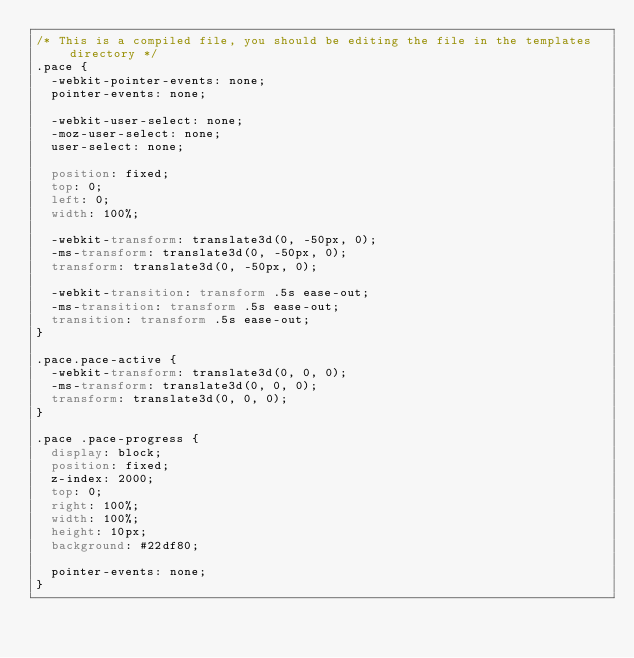Convert code to text. <code><loc_0><loc_0><loc_500><loc_500><_CSS_>/* This is a compiled file, you should be editing the file in the templates directory */
.pace {
  -webkit-pointer-events: none;
  pointer-events: none;

  -webkit-user-select: none;
  -moz-user-select: none;
  user-select: none;

  position: fixed;
  top: 0;
  left: 0;
  width: 100%;

  -webkit-transform: translate3d(0, -50px, 0);
  -ms-transform: translate3d(0, -50px, 0);
  transform: translate3d(0, -50px, 0);

  -webkit-transition: transform .5s ease-out;
  -ms-transition: transform .5s ease-out;
  transition: transform .5s ease-out;
}

.pace.pace-active {
  -webkit-transform: translate3d(0, 0, 0);
  -ms-transform: translate3d(0, 0, 0);
  transform: translate3d(0, 0, 0);
}

.pace .pace-progress {
  display: block;
  position: fixed;
  z-index: 2000;
  top: 0;
  right: 100%;
  width: 100%;
  height: 10px;
  background: #22df80;

  pointer-events: none;
}
</code> 